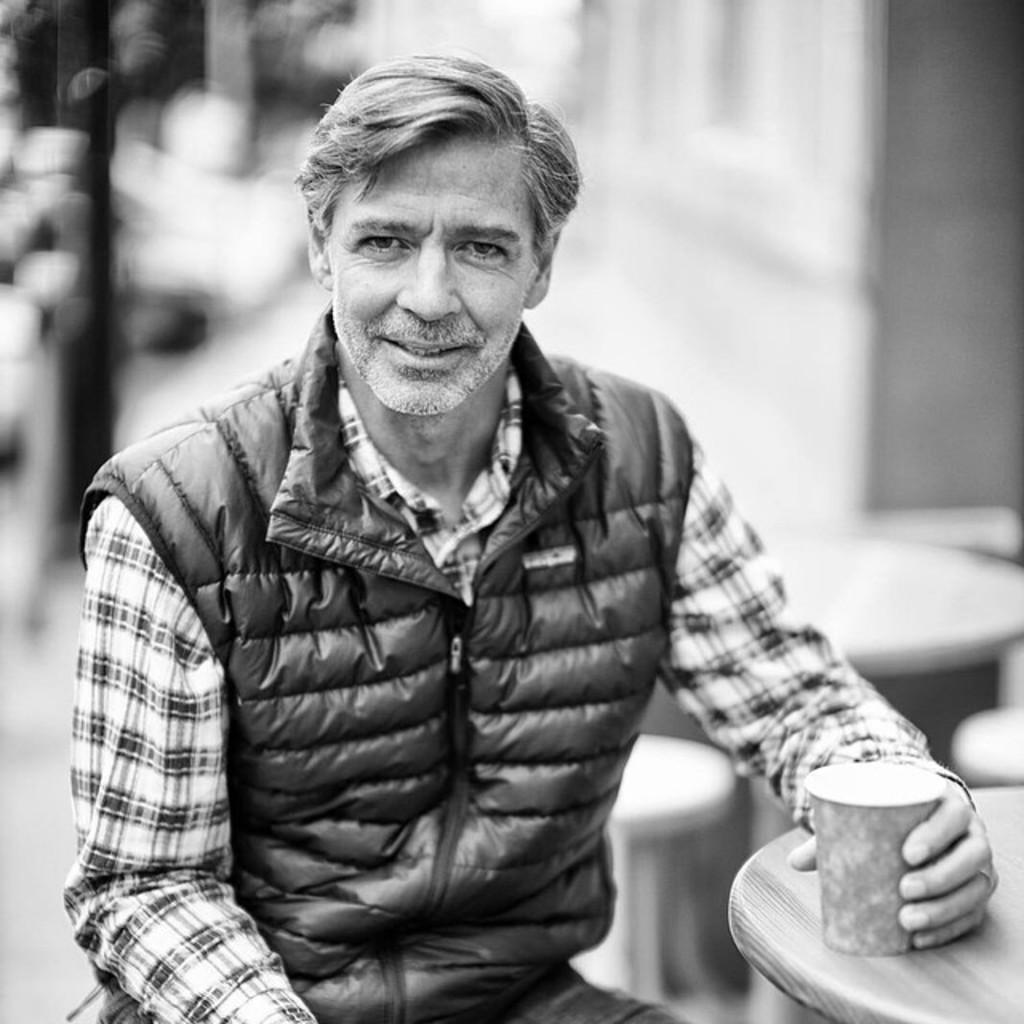Who is present in the image? There is a person in the image. What is the person wearing? The person is wearing a jacket. What is the person doing in the image? The person is sitting. What is the person holding in their hand? The person is holding a glass in their hand. Where is the glass placed in the image? The glass is placed on a table in the right corner of the image. What type of sound can be heard coming from the dinosaurs in the image? There are no dinosaurs present in the image, so no sound can be heard from them. 